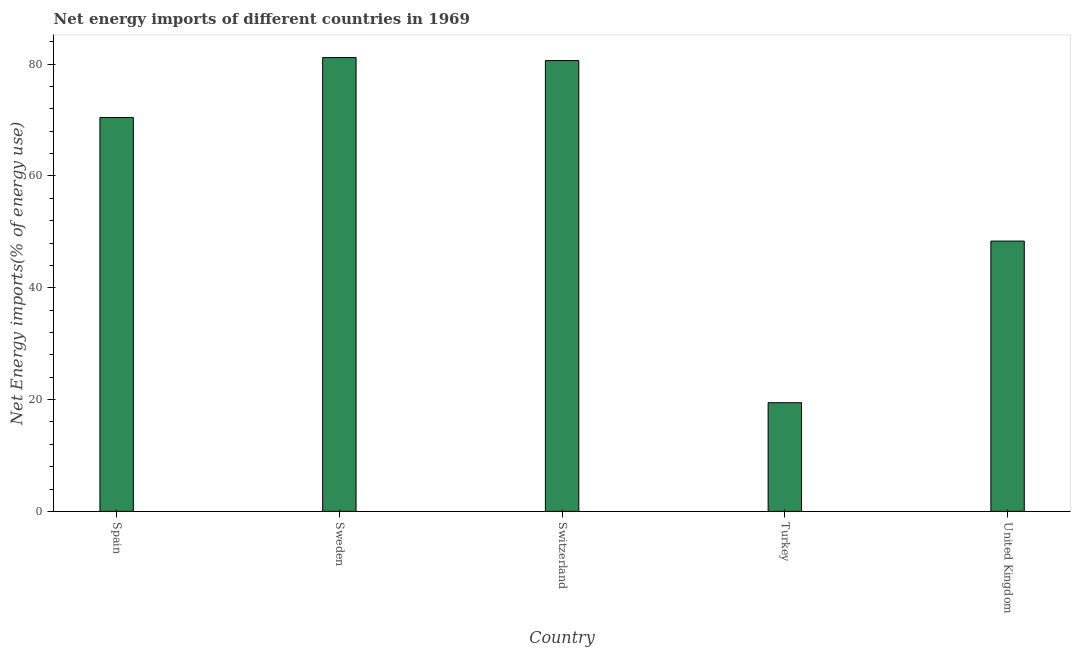Does the graph contain grids?
Your answer should be compact. No. What is the title of the graph?
Your answer should be compact. Net energy imports of different countries in 1969. What is the label or title of the X-axis?
Provide a short and direct response. Country. What is the label or title of the Y-axis?
Offer a terse response. Net Energy imports(% of energy use). What is the energy imports in United Kingdom?
Provide a short and direct response. 48.35. Across all countries, what is the maximum energy imports?
Give a very brief answer. 81.18. Across all countries, what is the minimum energy imports?
Provide a succinct answer. 19.44. In which country was the energy imports maximum?
Provide a short and direct response. Sweden. In which country was the energy imports minimum?
Your answer should be compact. Turkey. What is the sum of the energy imports?
Offer a terse response. 300.07. What is the difference between the energy imports in Spain and Turkey?
Provide a short and direct response. 51.02. What is the average energy imports per country?
Offer a terse response. 60.01. What is the median energy imports?
Make the answer very short. 70.46. What is the ratio of the energy imports in Switzerland to that in United Kingdom?
Provide a succinct answer. 1.67. Is the difference between the energy imports in Sweden and Turkey greater than the difference between any two countries?
Provide a succinct answer. Yes. What is the difference between the highest and the second highest energy imports?
Give a very brief answer. 0.54. Is the sum of the energy imports in Switzerland and United Kingdom greater than the maximum energy imports across all countries?
Give a very brief answer. Yes. What is the difference between the highest and the lowest energy imports?
Make the answer very short. 61.75. In how many countries, is the energy imports greater than the average energy imports taken over all countries?
Offer a terse response. 3. How many bars are there?
Give a very brief answer. 5. How many countries are there in the graph?
Offer a very short reply. 5. Are the values on the major ticks of Y-axis written in scientific E-notation?
Ensure brevity in your answer.  No. What is the Net Energy imports(% of energy use) in Spain?
Offer a terse response. 70.46. What is the Net Energy imports(% of energy use) in Sweden?
Keep it short and to the point. 81.18. What is the Net Energy imports(% of energy use) in Switzerland?
Your response must be concise. 80.64. What is the Net Energy imports(% of energy use) of Turkey?
Give a very brief answer. 19.44. What is the Net Energy imports(% of energy use) in United Kingdom?
Make the answer very short. 48.35. What is the difference between the Net Energy imports(% of energy use) in Spain and Sweden?
Keep it short and to the point. -10.72. What is the difference between the Net Energy imports(% of energy use) in Spain and Switzerland?
Keep it short and to the point. -10.18. What is the difference between the Net Energy imports(% of energy use) in Spain and Turkey?
Your response must be concise. 51.03. What is the difference between the Net Energy imports(% of energy use) in Spain and United Kingdom?
Provide a short and direct response. 22.11. What is the difference between the Net Energy imports(% of energy use) in Sweden and Switzerland?
Provide a succinct answer. 0.54. What is the difference between the Net Energy imports(% of energy use) in Sweden and Turkey?
Your answer should be compact. 61.75. What is the difference between the Net Energy imports(% of energy use) in Sweden and United Kingdom?
Your response must be concise. 32.83. What is the difference between the Net Energy imports(% of energy use) in Switzerland and Turkey?
Offer a very short reply. 61.21. What is the difference between the Net Energy imports(% of energy use) in Switzerland and United Kingdom?
Your answer should be very brief. 32.29. What is the difference between the Net Energy imports(% of energy use) in Turkey and United Kingdom?
Ensure brevity in your answer.  -28.91. What is the ratio of the Net Energy imports(% of energy use) in Spain to that in Sweden?
Your answer should be very brief. 0.87. What is the ratio of the Net Energy imports(% of energy use) in Spain to that in Switzerland?
Make the answer very short. 0.87. What is the ratio of the Net Energy imports(% of energy use) in Spain to that in Turkey?
Ensure brevity in your answer.  3.62. What is the ratio of the Net Energy imports(% of energy use) in Spain to that in United Kingdom?
Your answer should be very brief. 1.46. What is the ratio of the Net Energy imports(% of energy use) in Sweden to that in Switzerland?
Your answer should be compact. 1.01. What is the ratio of the Net Energy imports(% of energy use) in Sweden to that in Turkey?
Ensure brevity in your answer.  4.18. What is the ratio of the Net Energy imports(% of energy use) in Sweden to that in United Kingdom?
Ensure brevity in your answer.  1.68. What is the ratio of the Net Energy imports(% of energy use) in Switzerland to that in Turkey?
Make the answer very short. 4.15. What is the ratio of the Net Energy imports(% of energy use) in Switzerland to that in United Kingdom?
Ensure brevity in your answer.  1.67. What is the ratio of the Net Energy imports(% of energy use) in Turkey to that in United Kingdom?
Your answer should be compact. 0.4. 